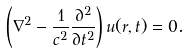<formula> <loc_0><loc_0><loc_500><loc_500>\left ( \nabla ^ { 2 } - { \frac { 1 } { c ^ { 2 } } } { \frac { \partial ^ { 2 } } { \partial t ^ { 2 } } } \right ) u ( r , t ) = 0 .</formula> 